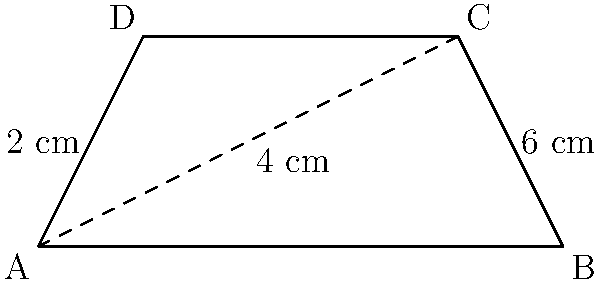As a freelance writer who values privacy and mental well-being, you've been tasked with creating an educational blog post about geometric shapes in nature. To illustrate the concept, you decide to use a trapezoid-shaped leaf as an example. The leaf's parallel sides measure 2 cm and 6 cm, with a height of 4 cm. Calculate the area of this trapezoid-shaped leaf to the nearest square centimeter. To calculate the area of a trapezoid, we'll use the formula:

$$A = \frac{1}{2}(b_1 + b_2)h$$

Where:
$A$ = Area of the trapezoid
$b_1$ and $b_2$ = Lengths of the parallel sides
$h$ = Height of the trapezoid

Given:
$b_1 = 2$ cm
$b_2 = 6$ cm
$h = 4$ cm

Let's substitute these values into the formula:

$$A = \frac{1}{2}(2 + 6) \times 4$$

$$A = \frac{1}{2}(8) \times 4$$

$$A = 4 \times 4$$

$$A = 16$$

Therefore, the area of the trapezoid-shaped leaf is 16 square centimeters.
Answer: 16 cm² 